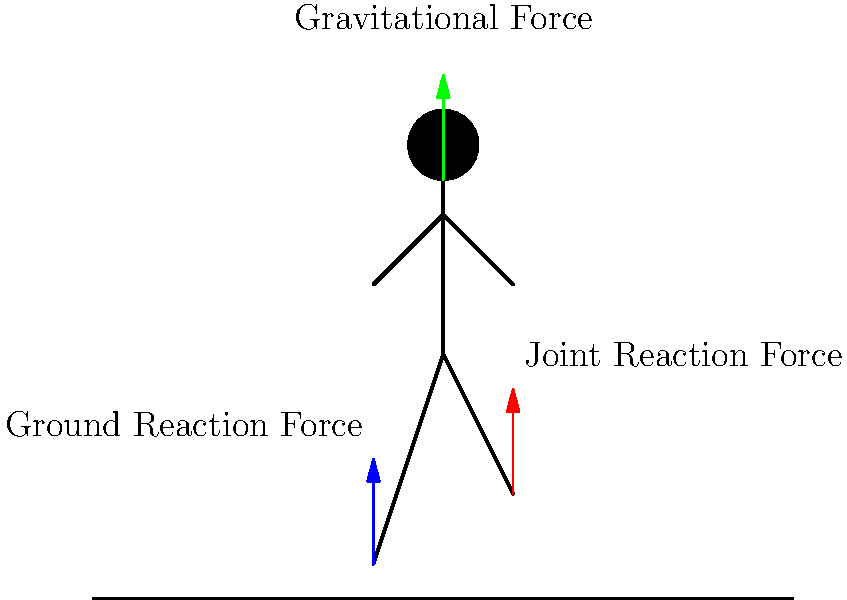As a top-level editor overseeing health and fitness content, you're reviewing an article about running biomechanics. The article discusses the forces acting on a runner's joints during the stance phase of a stride. Based on the diagram, which force is likely to have the greatest impact on joint stress and potential injury risk for runners? To answer this question, let's analyze the forces shown in the diagram:

1. Gravitational Force (green arrow):
   - This is a constant downward force due to the runner's body weight.
   - It remains relatively consistent throughout the running motion.

2. Joint Reaction Force (red arrow):
   - This represents the internal force within the joints as they react to external forces.
   - It's a result of muscle activity and other forces acting on the body.

3. Ground Reaction Force (blue arrow):
   - This is the force exerted by the ground on the runner's foot during contact.
   - It varies in magnitude throughout the stance phase and can be several times the runner's body weight.

The Ground Reaction Force is likely to have the greatest impact on joint stress and injury risk for several reasons:

1. Magnitude: During running, the Ground Reaction Force can reach 2-3 times the runner's body weight, which is significantly higher than the other forces.

2. Variability: This force changes rapidly during the stance phase, from initial contact to toe-off, creating sudden loading on the joints.

3. Transmission: The force is transmitted through the entire kinetic chain (foot, ankle, knee, hip, and spine), affecting multiple joints.

4. Impact: High Ground Reaction Forces, especially during heel strikes, can lead to increased shock and vibration through the body.

5. Modifiability: Factors like running technique, footwear, and surface can influence this force, making it a key focus for injury prevention strategies.

While all forces play a role in running biomechanics, the Ground Reaction Force is particularly crucial for understanding and mitigating joint stress and injury risk in runners.
Answer: Ground Reaction Force 